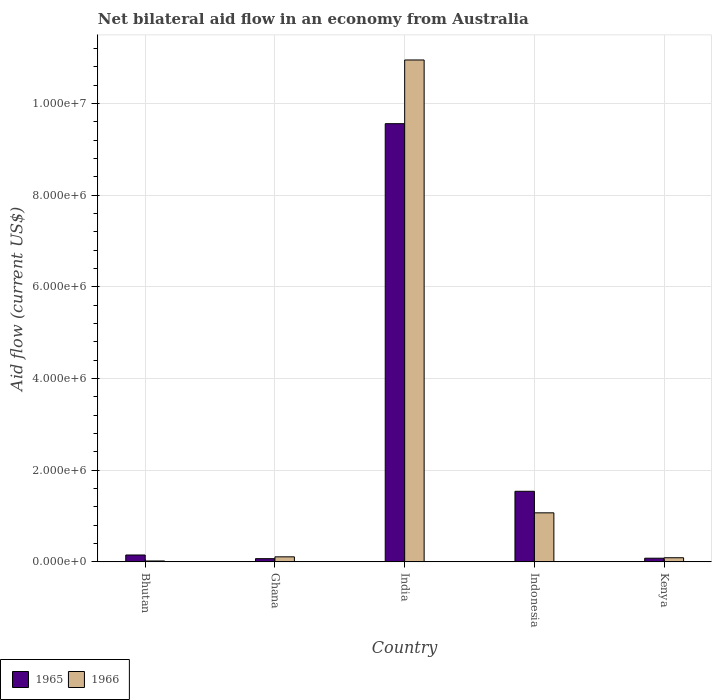Are the number of bars per tick equal to the number of legend labels?
Your answer should be compact. Yes. How many bars are there on the 5th tick from the right?
Provide a succinct answer. 2. What is the label of the 5th group of bars from the left?
Make the answer very short. Kenya. In how many cases, is the number of bars for a given country not equal to the number of legend labels?
Give a very brief answer. 0. What is the net bilateral aid flow in 1966 in Ghana?
Your answer should be very brief. 1.10e+05. Across all countries, what is the maximum net bilateral aid flow in 1965?
Your response must be concise. 9.56e+06. In which country was the net bilateral aid flow in 1966 minimum?
Offer a very short reply. Bhutan. What is the total net bilateral aid flow in 1965 in the graph?
Your response must be concise. 1.14e+07. What is the difference between the net bilateral aid flow in 1965 in Ghana and that in Indonesia?
Keep it short and to the point. -1.47e+06. What is the average net bilateral aid flow in 1965 per country?
Your answer should be very brief. 2.28e+06. What is the difference between the net bilateral aid flow of/in 1966 and net bilateral aid flow of/in 1965 in India?
Your answer should be very brief. 1.39e+06. In how many countries, is the net bilateral aid flow in 1966 greater than 1600000 US$?
Your answer should be very brief. 1. What is the ratio of the net bilateral aid flow in 1965 in Bhutan to that in Ghana?
Provide a short and direct response. 2.14. Is the net bilateral aid flow in 1965 in Ghana less than that in Kenya?
Keep it short and to the point. Yes. What is the difference between the highest and the second highest net bilateral aid flow in 1966?
Make the answer very short. 1.08e+07. What is the difference between the highest and the lowest net bilateral aid flow in 1966?
Your response must be concise. 1.09e+07. Is the sum of the net bilateral aid flow in 1966 in Bhutan and India greater than the maximum net bilateral aid flow in 1965 across all countries?
Ensure brevity in your answer.  Yes. What does the 2nd bar from the left in Indonesia represents?
Make the answer very short. 1966. What does the 1st bar from the right in India represents?
Offer a very short reply. 1966. Are all the bars in the graph horizontal?
Ensure brevity in your answer.  No. Are the values on the major ticks of Y-axis written in scientific E-notation?
Ensure brevity in your answer.  Yes. Where does the legend appear in the graph?
Offer a terse response. Bottom left. How many legend labels are there?
Your answer should be very brief. 2. What is the title of the graph?
Give a very brief answer. Net bilateral aid flow in an economy from Australia. Does "1984" appear as one of the legend labels in the graph?
Provide a succinct answer. No. What is the label or title of the Y-axis?
Your answer should be very brief. Aid flow (current US$). What is the Aid flow (current US$) in 1966 in Bhutan?
Offer a very short reply. 2.00e+04. What is the Aid flow (current US$) in 1965 in Ghana?
Offer a terse response. 7.00e+04. What is the Aid flow (current US$) in 1966 in Ghana?
Offer a terse response. 1.10e+05. What is the Aid flow (current US$) of 1965 in India?
Your response must be concise. 9.56e+06. What is the Aid flow (current US$) of 1966 in India?
Ensure brevity in your answer.  1.10e+07. What is the Aid flow (current US$) in 1965 in Indonesia?
Your response must be concise. 1.54e+06. What is the Aid flow (current US$) of 1966 in Indonesia?
Provide a succinct answer. 1.07e+06. Across all countries, what is the maximum Aid flow (current US$) in 1965?
Make the answer very short. 9.56e+06. Across all countries, what is the maximum Aid flow (current US$) in 1966?
Provide a short and direct response. 1.10e+07. What is the total Aid flow (current US$) of 1965 in the graph?
Keep it short and to the point. 1.14e+07. What is the total Aid flow (current US$) of 1966 in the graph?
Provide a succinct answer. 1.22e+07. What is the difference between the Aid flow (current US$) in 1965 in Bhutan and that in Ghana?
Your answer should be compact. 8.00e+04. What is the difference between the Aid flow (current US$) of 1966 in Bhutan and that in Ghana?
Ensure brevity in your answer.  -9.00e+04. What is the difference between the Aid flow (current US$) of 1965 in Bhutan and that in India?
Your response must be concise. -9.41e+06. What is the difference between the Aid flow (current US$) of 1966 in Bhutan and that in India?
Your response must be concise. -1.09e+07. What is the difference between the Aid flow (current US$) in 1965 in Bhutan and that in Indonesia?
Make the answer very short. -1.39e+06. What is the difference between the Aid flow (current US$) in 1966 in Bhutan and that in Indonesia?
Keep it short and to the point. -1.05e+06. What is the difference between the Aid flow (current US$) of 1965 in Ghana and that in India?
Provide a short and direct response. -9.49e+06. What is the difference between the Aid flow (current US$) of 1966 in Ghana and that in India?
Provide a succinct answer. -1.08e+07. What is the difference between the Aid flow (current US$) of 1965 in Ghana and that in Indonesia?
Offer a terse response. -1.47e+06. What is the difference between the Aid flow (current US$) in 1966 in Ghana and that in Indonesia?
Offer a terse response. -9.60e+05. What is the difference between the Aid flow (current US$) in 1965 in Ghana and that in Kenya?
Your answer should be very brief. -10000. What is the difference between the Aid flow (current US$) of 1965 in India and that in Indonesia?
Ensure brevity in your answer.  8.02e+06. What is the difference between the Aid flow (current US$) of 1966 in India and that in Indonesia?
Ensure brevity in your answer.  9.88e+06. What is the difference between the Aid flow (current US$) in 1965 in India and that in Kenya?
Ensure brevity in your answer.  9.48e+06. What is the difference between the Aid flow (current US$) in 1966 in India and that in Kenya?
Ensure brevity in your answer.  1.09e+07. What is the difference between the Aid flow (current US$) in 1965 in Indonesia and that in Kenya?
Keep it short and to the point. 1.46e+06. What is the difference between the Aid flow (current US$) of 1966 in Indonesia and that in Kenya?
Offer a terse response. 9.80e+05. What is the difference between the Aid flow (current US$) in 1965 in Bhutan and the Aid flow (current US$) in 1966 in Ghana?
Provide a short and direct response. 4.00e+04. What is the difference between the Aid flow (current US$) of 1965 in Bhutan and the Aid flow (current US$) of 1966 in India?
Offer a very short reply. -1.08e+07. What is the difference between the Aid flow (current US$) in 1965 in Bhutan and the Aid flow (current US$) in 1966 in Indonesia?
Offer a terse response. -9.20e+05. What is the difference between the Aid flow (current US$) of 1965 in Bhutan and the Aid flow (current US$) of 1966 in Kenya?
Provide a succinct answer. 6.00e+04. What is the difference between the Aid flow (current US$) of 1965 in Ghana and the Aid flow (current US$) of 1966 in India?
Give a very brief answer. -1.09e+07. What is the difference between the Aid flow (current US$) in 1965 in Ghana and the Aid flow (current US$) in 1966 in Indonesia?
Ensure brevity in your answer.  -1.00e+06. What is the difference between the Aid flow (current US$) in 1965 in India and the Aid flow (current US$) in 1966 in Indonesia?
Provide a short and direct response. 8.49e+06. What is the difference between the Aid flow (current US$) in 1965 in India and the Aid flow (current US$) in 1966 in Kenya?
Keep it short and to the point. 9.47e+06. What is the difference between the Aid flow (current US$) in 1965 in Indonesia and the Aid flow (current US$) in 1966 in Kenya?
Offer a terse response. 1.45e+06. What is the average Aid flow (current US$) in 1965 per country?
Give a very brief answer. 2.28e+06. What is the average Aid flow (current US$) in 1966 per country?
Your answer should be compact. 2.45e+06. What is the difference between the Aid flow (current US$) in 1965 and Aid flow (current US$) in 1966 in Bhutan?
Ensure brevity in your answer.  1.30e+05. What is the difference between the Aid flow (current US$) in 1965 and Aid flow (current US$) in 1966 in Ghana?
Offer a terse response. -4.00e+04. What is the difference between the Aid flow (current US$) in 1965 and Aid flow (current US$) in 1966 in India?
Give a very brief answer. -1.39e+06. What is the difference between the Aid flow (current US$) in 1965 and Aid flow (current US$) in 1966 in Indonesia?
Provide a succinct answer. 4.70e+05. What is the ratio of the Aid flow (current US$) in 1965 in Bhutan to that in Ghana?
Offer a very short reply. 2.14. What is the ratio of the Aid flow (current US$) in 1966 in Bhutan to that in Ghana?
Offer a very short reply. 0.18. What is the ratio of the Aid flow (current US$) of 1965 in Bhutan to that in India?
Provide a short and direct response. 0.02. What is the ratio of the Aid flow (current US$) of 1966 in Bhutan to that in India?
Provide a succinct answer. 0. What is the ratio of the Aid flow (current US$) in 1965 in Bhutan to that in Indonesia?
Ensure brevity in your answer.  0.1. What is the ratio of the Aid flow (current US$) of 1966 in Bhutan to that in Indonesia?
Give a very brief answer. 0.02. What is the ratio of the Aid flow (current US$) in 1965 in Bhutan to that in Kenya?
Provide a succinct answer. 1.88. What is the ratio of the Aid flow (current US$) of 1966 in Bhutan to that in Kenya?
Provide a succinct answer. 0.22. What is the ratio of the Aid flow (current US$) in 1965 in Ghana to that in India?
Make the answer very short. 0.01. What is the ratio of the Aid flow (current US$) in 1966 in Ghana to that in India?
Offer a very short reply. 0.01. What is the ratio of the Aid flow (current US$) of 1965 in Ghana to that in Indonesia?
Ensure brevity in your answer.  0.05. What is the ratio of the Aid flow (current US$) in 1966 in Ghana to that in Indonesia?
Provide a short and direct response. 0.1. What is the ratio of the Aid flow (current US$) of 1966 in Ghana to that in Kenya?
Your response must be concise. 1.22. What is the ratio of the Aid flow (current US$) in 1965 in India to that in Indonesia?
Offer a terse response. 6.21. What is the ratio of the Aid flow (current US$) of 1966 in India to that in Indonesia?
Offer a terse response. 10.23. What is the ratio of the Aid flow (current US$) of 1965 in India to that in Kenya?
Your answer should be very brief. 119.5. What is the ratio of the Aid flow (current US$) in 1966 in India to that in Kenya?
Offer a terse response. 121.67. What is the ratio of the Aid flow (current US$) of 1965 in Indonesia to that in Kenya?
Provide a short and direct response. 19.25. What is the ratio of the Aid flow (current US$) in 1966 in Indonesia to that in Kenya?
Offer a very short reply. 11.89. What is the difference between the highest and the second highest Aid flow (current US$) in 1965?
Give a very brief answer. 8.02e+06. What is the difference between the highest and the second highest Aid flow (current US$) in 1966?
Offer a terse response. 9.88e+06. What is the difference between the highest and the lowest Aid flow (current US$) in 1965?
Provide a short and direct response. 9.49e+06. What is the difference between the highest and the lowest Aid flow (current US$) of 1966?
Your answer should be compact. 1.09e+07. 